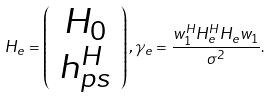<formula> <loc_0><loc_0><loc_500><loc_500>H _ { e } = \left ( \begin{array} { c } H _ { 0 } \\ h _ { p s } ^ { H } \end{array} \right ) , \gamma _ { e } = \frac { w _ { 1 } ^ { H } H _ { e } ^ { H } H _ { e } w _ { 1 } } { \sigma ^ { 2 } } .</formula> 